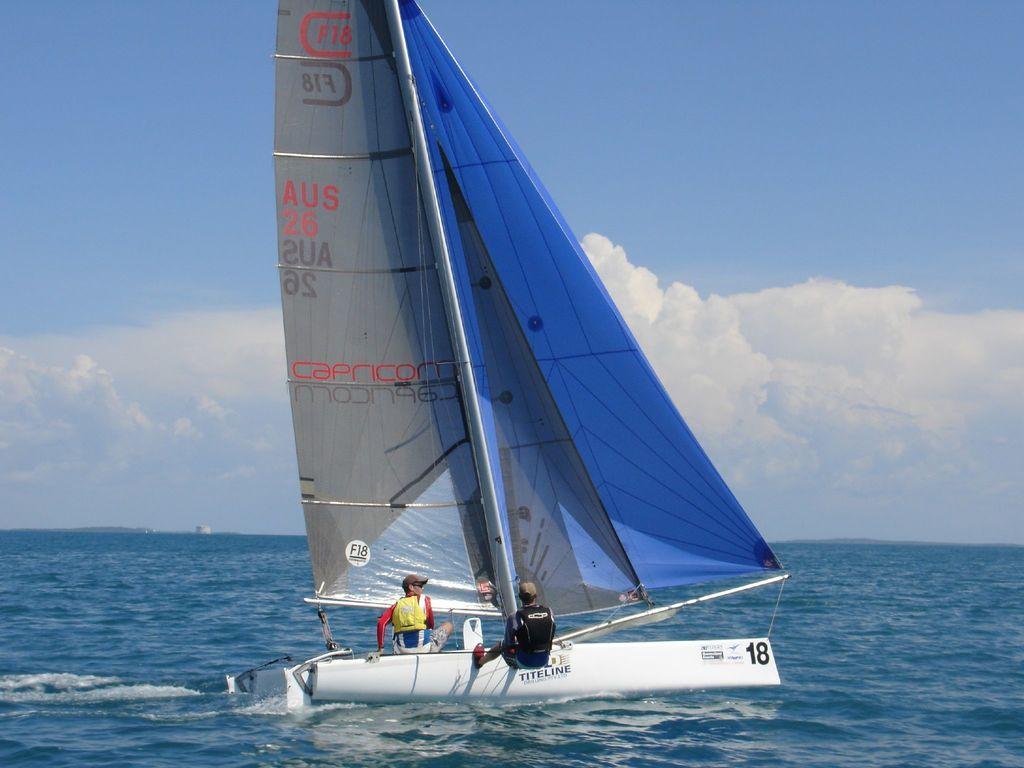Please provide a concise description of this image. As we can see in the image there are two people on boat. There is water, sky and clouds. 